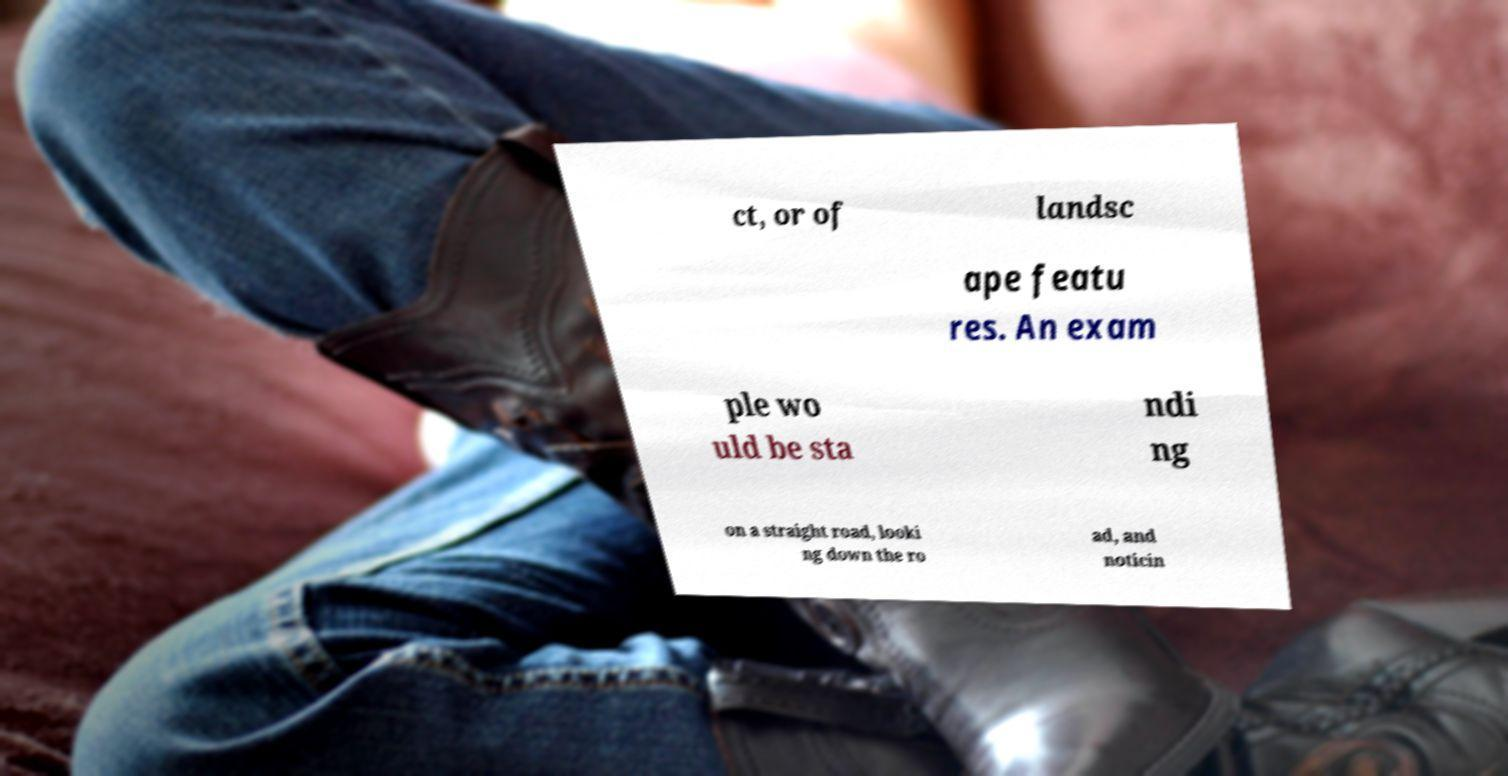Can you read and provide the text displayed in the image?This photo seems to have some interesting text. Can you extract and type it out for me? ct, or of landsc ape featu res. An exam ple wo uld be sta ndi ng on a straight road, looki ng down the ro ad, and noticin 